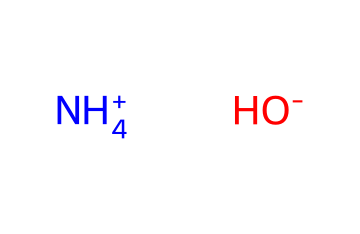What is the total number of atoms in ammonium hydroxide? The SMILES representation shows two parts: ammonium (NH4+) and hydroxide (OH-). Ammonium has 4 hydrogen atoms and 1 nitrogen atom, while hydroxide has 1 oxygen atom and 1 hydrogen atom. Adding these together gives a total of 6 atoms.
Answer: 6 What is the molecular weight of ammonium hydroxide? Ammonium (NH4+) consists of nitrogen (14.01 g/mol) and four hydrogens (4 x 1.01 g/mol = 4.04 g/mol). Hydroxide (OH-) consists of one oxygen (16.00 g/mol) and one hydrogen (1.01 g/mol). Therefore, the total molecular weight is 14.01 + 4.04 + 16.00 + 1.01 = 35.06 g/mol.
Answer: 35.06 g/mol Which ions are present in ammonium hydroxide? The SMILES notation indicates the presence of ammonium ion (NH4+) and hydroxide ion (OH-). These are the two ions derived from the molecular arrangement shown.
Answer: ammonium ion and hydroxide ion What type of compound is ammonium hydroxide classified as? The presence of hydroxide ions (OH-) indicates it is a base, as bases are characterized by the presence of hydroxide. Therefore, ammonium hydroxide fits the definition of a base.
Answer: base How does the molecular arrangement affect the pH of the solution? Ammonium hydroxide dissociates in water to produce hydroxide ions, which increase the concentration of hydroxide and thus increase the pH. A higher pH indicates a more basic solution.
Answer: increases pH What kind of chemical bond is present in ammonium hydroxide? The ammonium ion is connected to the hydroxide ion through ionic bonding, which occurs due to the electrostatic attraction between the positively charged ammonium ion and the negatively charged hydroxide ion.
Answer: ionic bond In what types of commercial cleaning products is ammonium hydroxide commonly found? Ammonium hydroxide can be found in glass cleaners, household ammonia solutions, and other general-purpose cleaners, where its properties help in removing grease and dirt.
Answer: glass cleaners and household ammonia solutions 